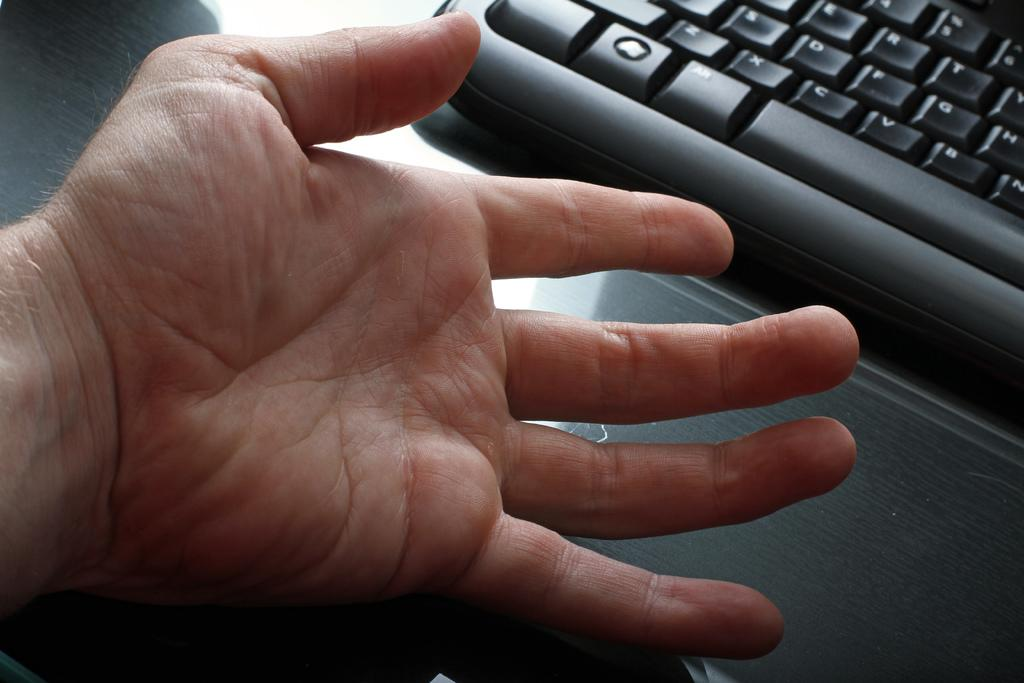<image>
Summarize the visual content of the image. The Alt button of a keyboard can be seen in front of a hand. 